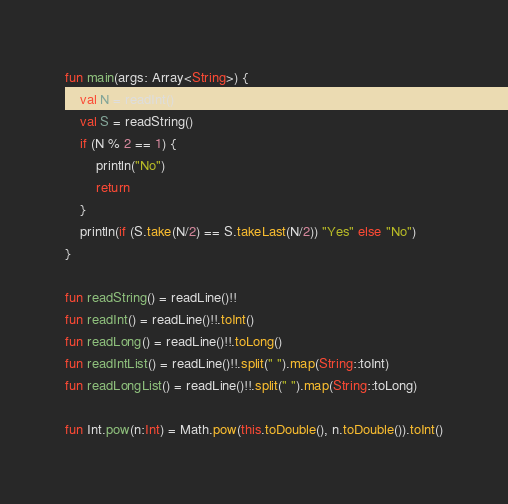Convert code to text. <code><loc_0><loc_0><loc_500><loc_500><_Kotlin_>fun main(args: Array<String>) {
    val N = readInt()
    val S = readString()
    if (N % 2 == 1) {
        println("No")
        return
    }
    println(if (S.take(N/2) == S.takeLast(N/2)) "Yes" else "No")
}

fun readString() = readLine()!!
fun readInt() = readLine()!!.toInt()
fun readLong() = readLine()!!.toLong()
fun readIntList() = readLine()!!.split(" ").map(String::toInt)
fun readLongList() = readLine()!!.split(" ").map(String::toLong)

fun Int.pow(n:Int) = Math.pow(this.toDouble(), n.toDouble()).toInt()</code> 